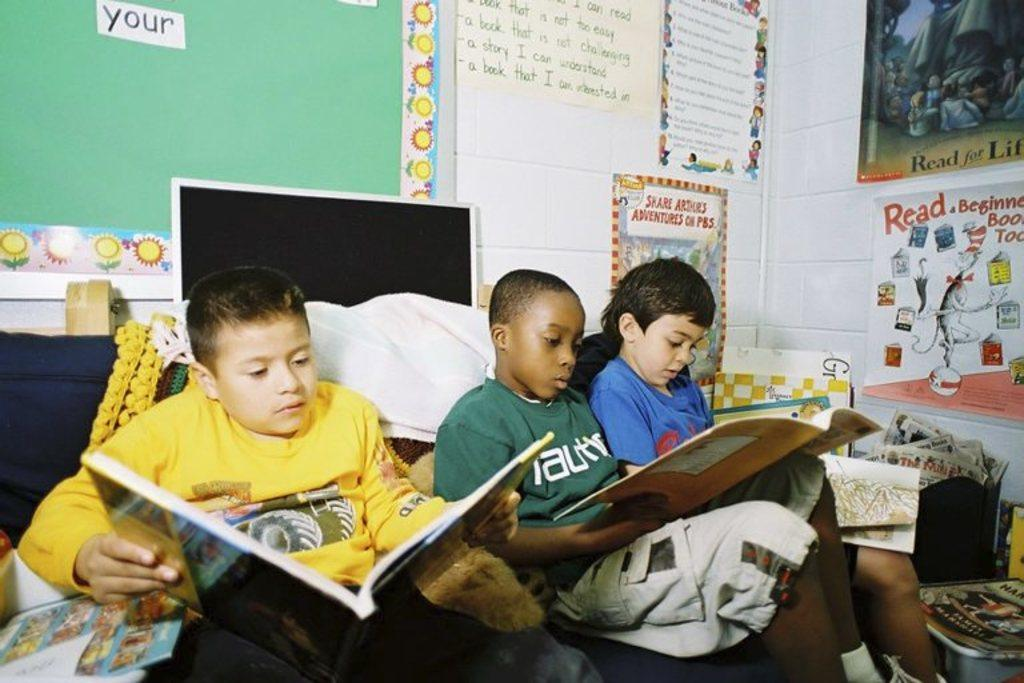Provide a one-sentence caption for the provided image. Boys reading in front of a board that says "your" on it. 